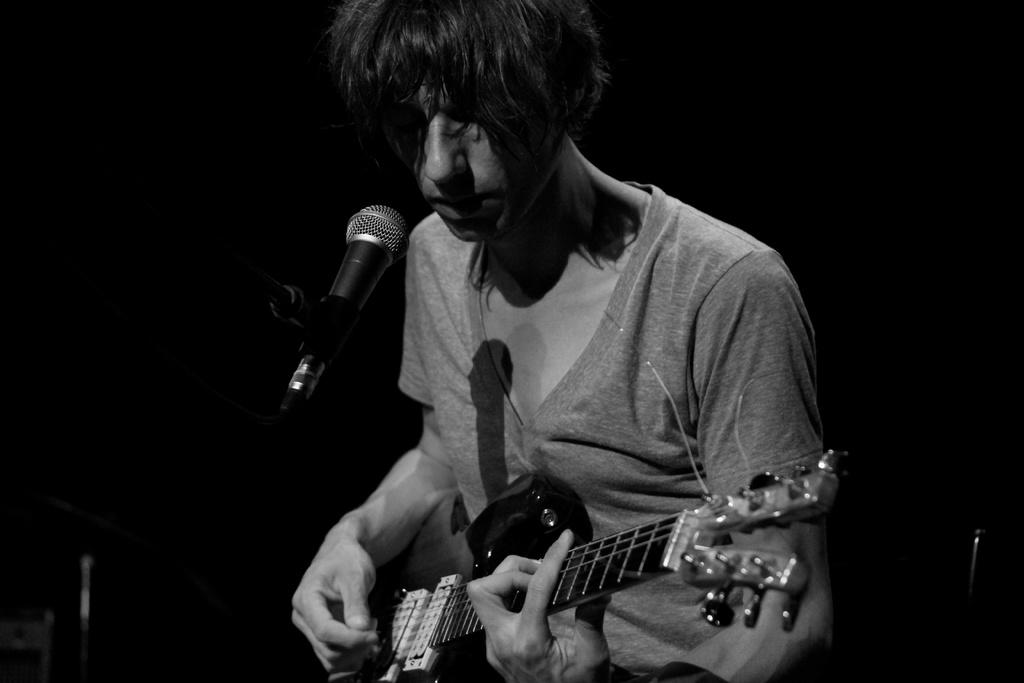What is the man in the image doing? The man is playing a guitar in the image. What object is present in the image that is typically used for amplifying sound? There is a microphone (mike) in the image. What type of country is depicted in the background of the image? There is no country depicted in the image; it only features a man playing a guitar and a microphone. How many tomatoes can be seen in the image? There are no tomatoes present in the image. 